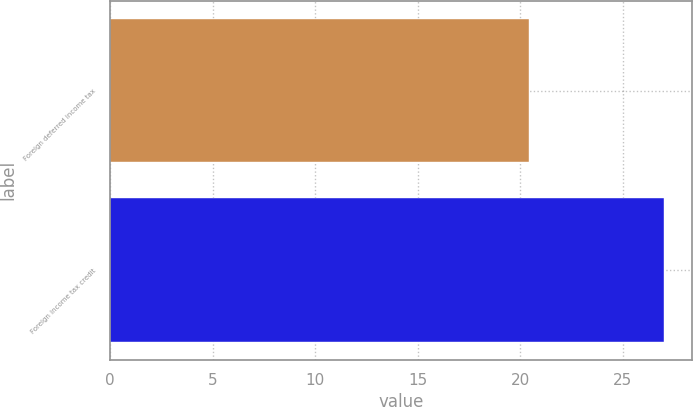<chart> <loc_0><loc_0><loc_500><loc_500><bar_chart><fcel>Foreign deferred income tax<fcel>Foreign income tax credit<nl><fcel>20.4<fcel>27<nl></chart> 